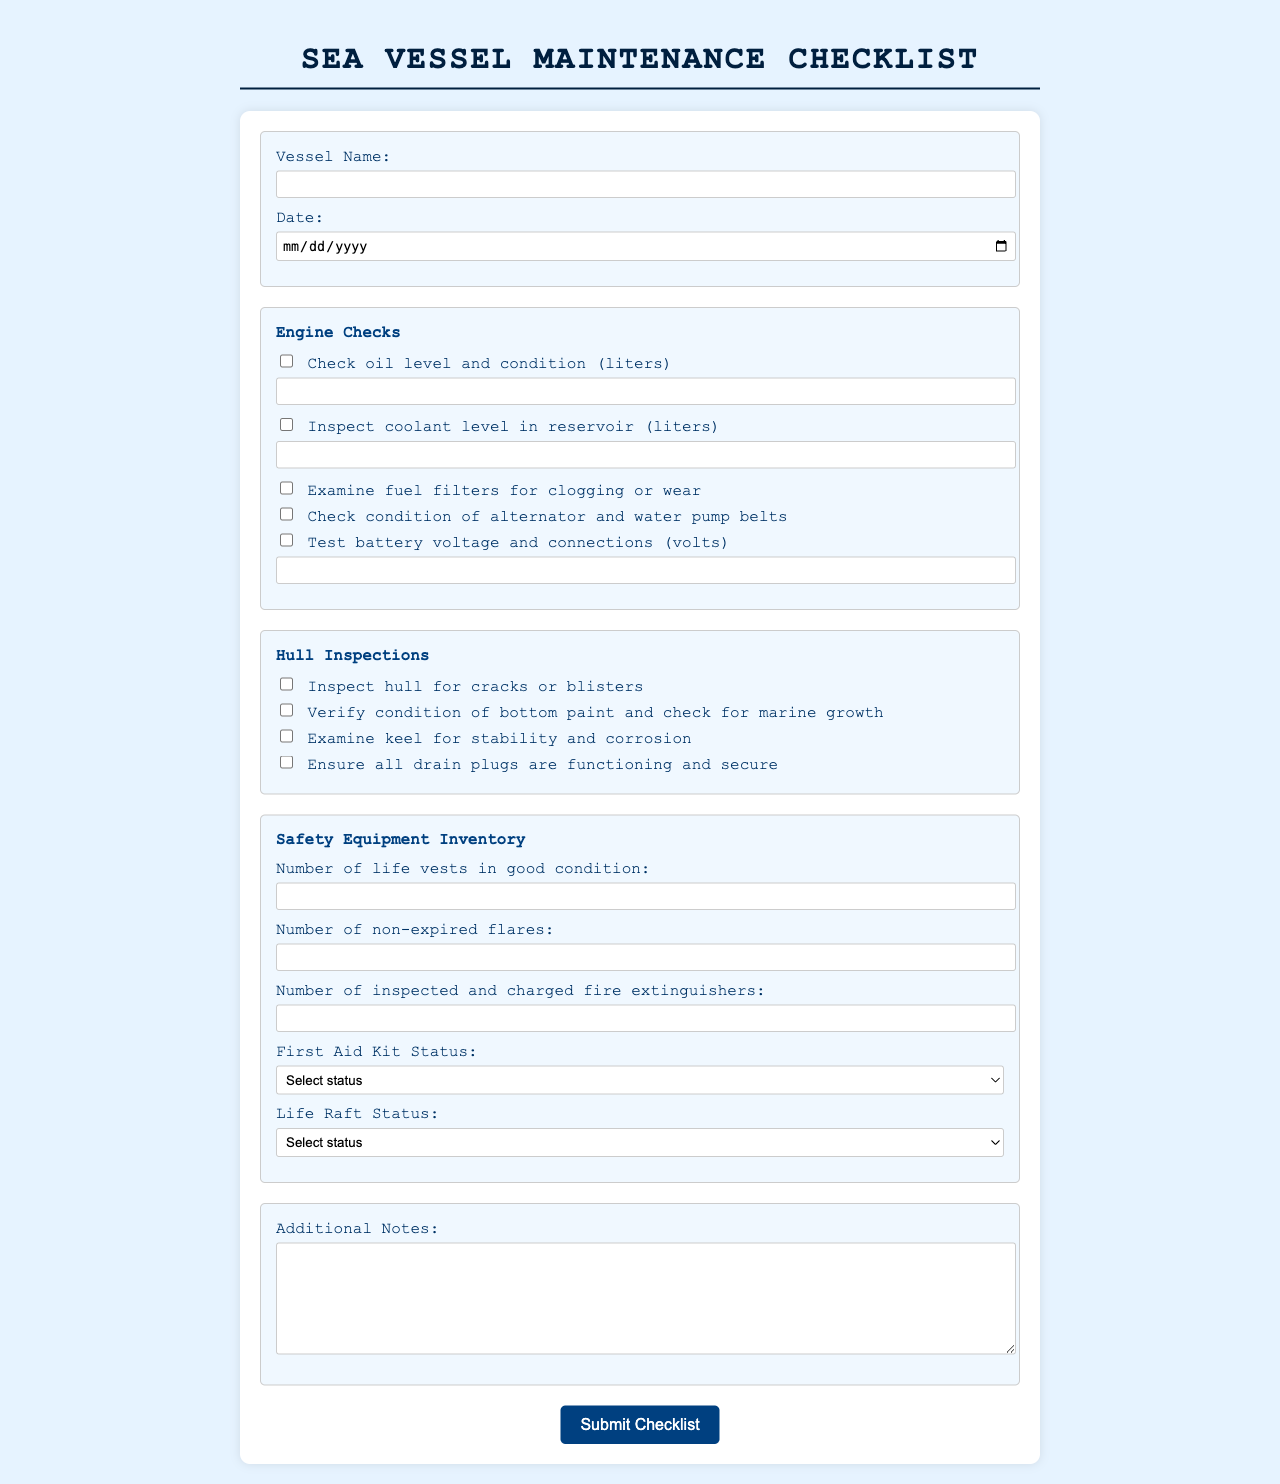what is the vessel name field for? It is a required field for entering the name of the vessel being inspected.
Answer: Vessel Name what is the date field for? It is a required field for entering the date of the maintenance checklist.
Answer: Date how many checks are listed under Engine Checks? The section lists five specific checks for the engine.
Answer: Five what is the required status for the First Aid Kit? This requires selecting the current status of the First Aid Kit from a dropdown menu.
Answer: Complete or In need of resupply what should be examined for stability and corrosion? This refers to the condition that needs to be checked under Hull Inspections.
Answer: Keel how many life vests are required to be counted? This is a required field for entering the number of life vests available in good condition.
Answer: A number (minimum is 0) what is the purpose of checking battery voltage? This check is to ensure that the battery is functional and properly connected.
Answer: To test battery voltage and connections which equipment requires a status selection? Both the First Aid Kit and Life Raft require a status selection.
Answer: First Aid Kit and Life Raft what is the checkbox option for oil checks? This checkbox asks whether to check the oil level and condition in liters.
Answer: Check oil level and condition (liters) 